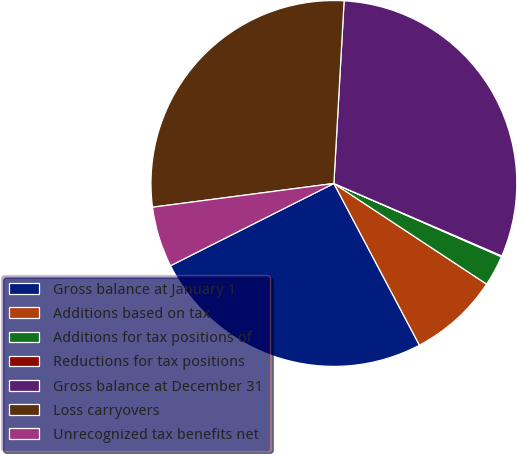Convert chart to OTSL. <chart><loc_0><loc_0><loc_500><loc_500><pie_chart><fcel>Gross balance at January 1<fcel>Additions based on tax<fcel>Additions for tax positions of<fcel>Reductions for tax positions<fcel>Gross balance at December 31<fcel>Loss carryovers<fcel>Unrecognized tax benefits net<nl><fcel>25.32%<fcel>7.98%<fcel>2.71%<fcel>0.08%<fcel>30.59%<fcel>27.96%<fcel>5.35%<nl></chart> 